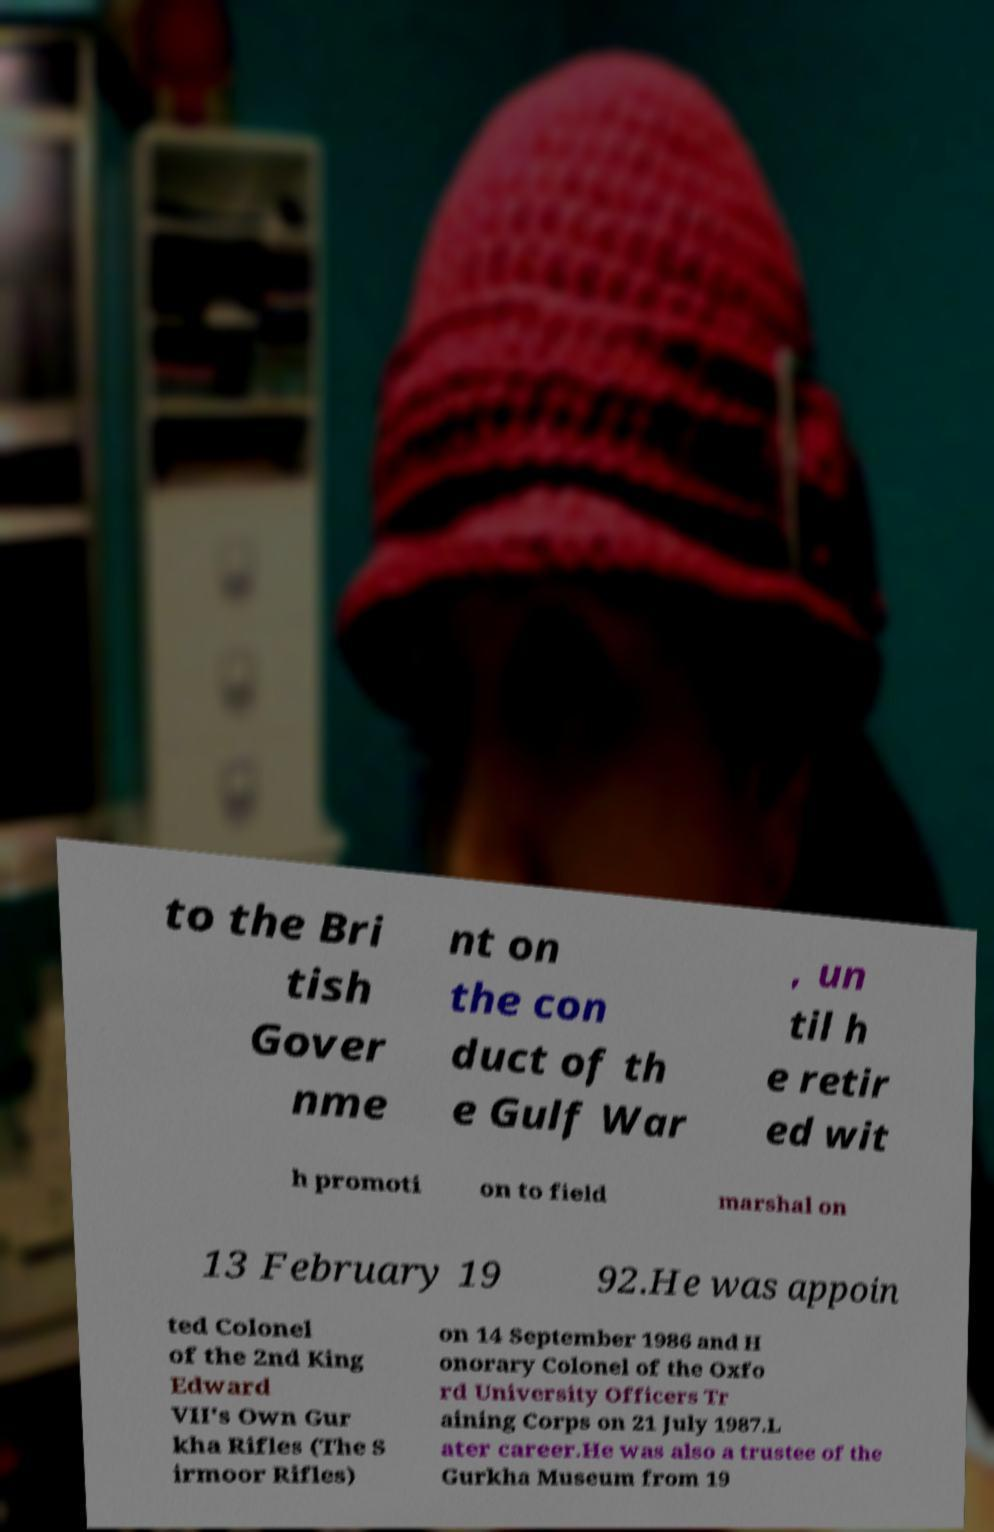Please identify and transcribe the text found in this image. to the Bri tish Gover nme nt on the con duct of th e Gulf War , un til h e retir ed wit h promoti on to field marshal on 13 February 19 92.He was appoin ted Colonel of the 2nd King Edward VII's Own Gur kha Rifles (The S irmoor Rifles) on 14 September 1986 and H onorary Colonel of the Oxfo rd University Officers Tr aining Corps on 21 July 1987.L ater career.He was also a trustee of the Gurkha Museum from 19 